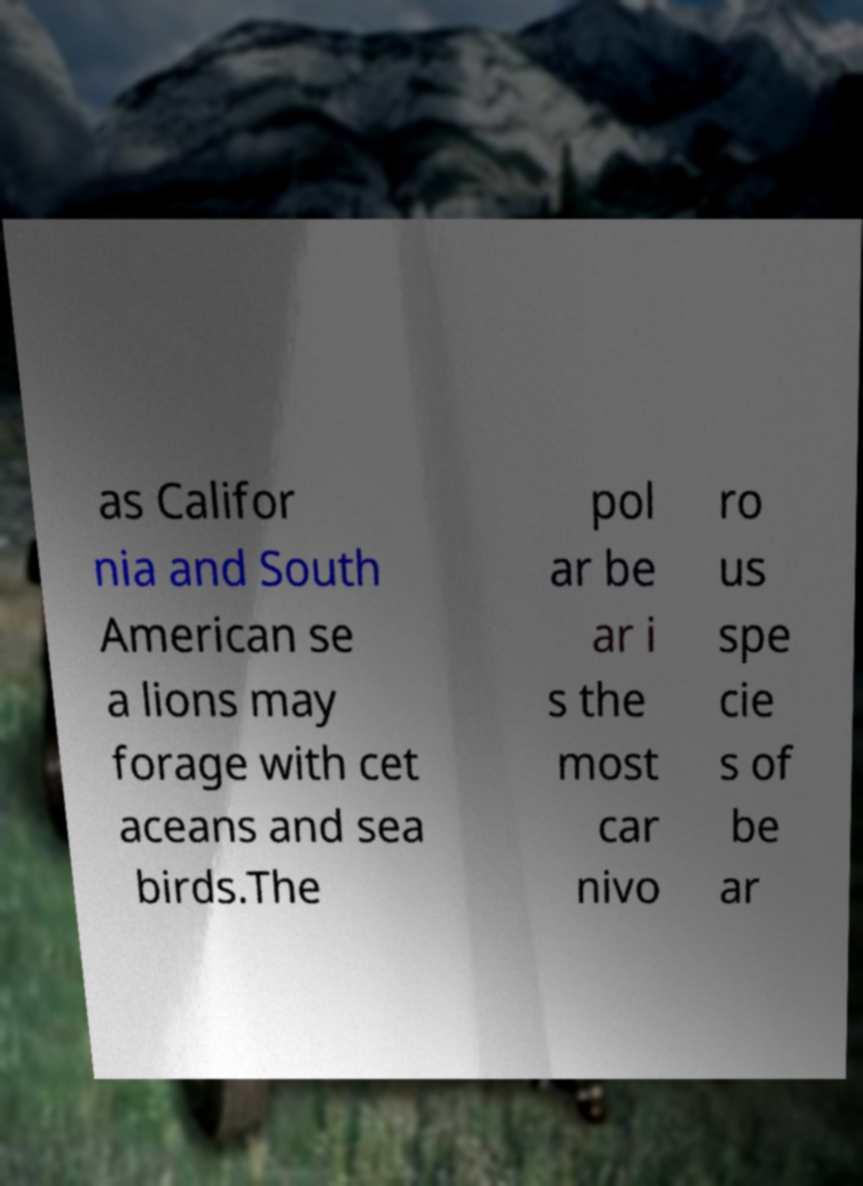Please identify and transcribe the text found in this image. as Califor nia and South American se a lions may forage with cet aceans and sea birds.The pol ar be ar i s the most car nivo ro us spe cie s of be ar 